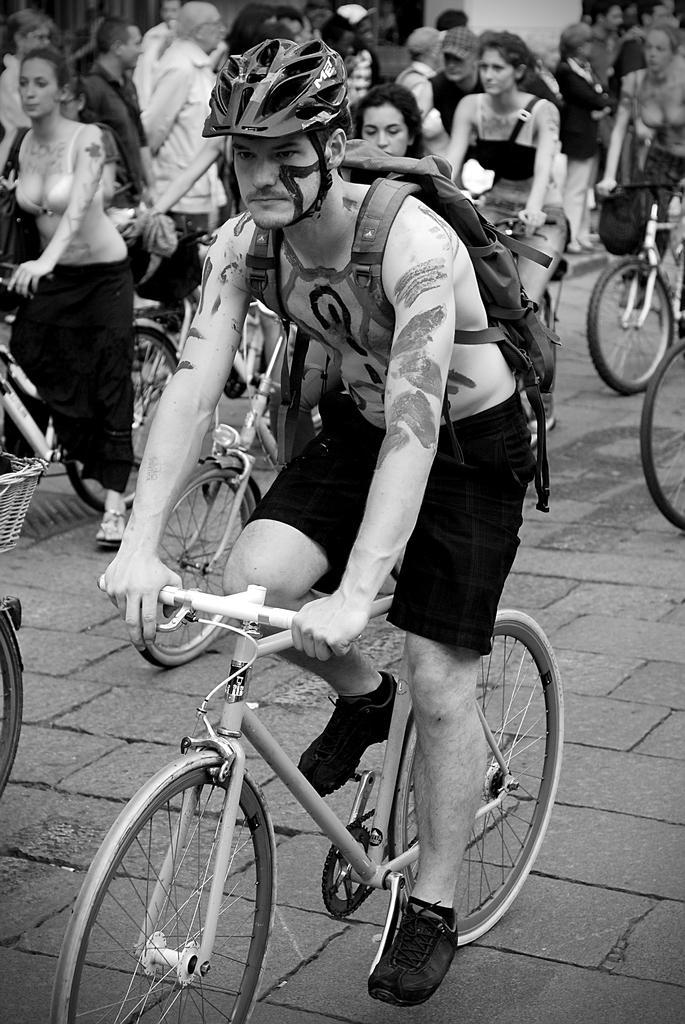Please provide a concise description of this image. This is a black and white picture. Here we can see persons riding bicycles and on the background we can see few persons are standing. 